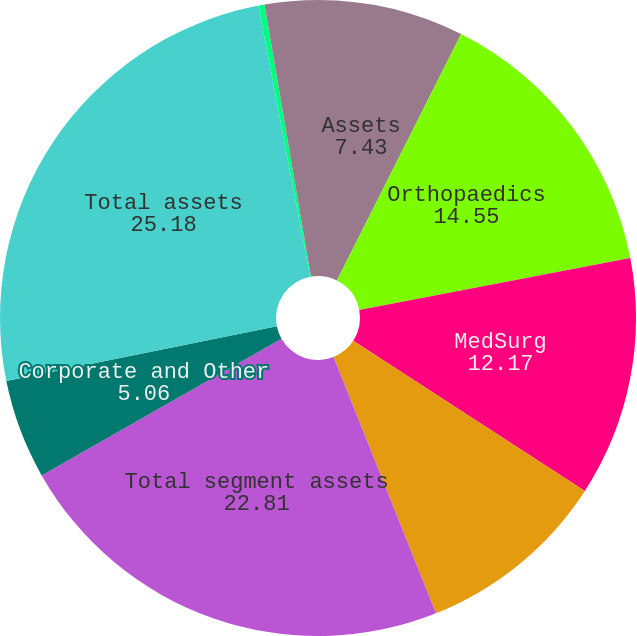Convert chart to OTSL. <chart><loc_0><loc_0><loc_500><loc_500><pie_chart><fcel>Assets<fcel>Orthopaedics<fcel>MedSurg<fcel>Neurotechnology & Spine<fcel>Total segment assets<fcel>Corporate and Other<fcel>Total assets<fcel>Total segment capital spending<fcel>Total capital spending<nl><fcel>7.43%<fcel>14.55%<fcel>12.17%<fcel>9.8%<fcel>22.81%<fcel>5.06%<fcel>25.18%<fcel>0.31%<fcel>2.69%<nl></chart> 